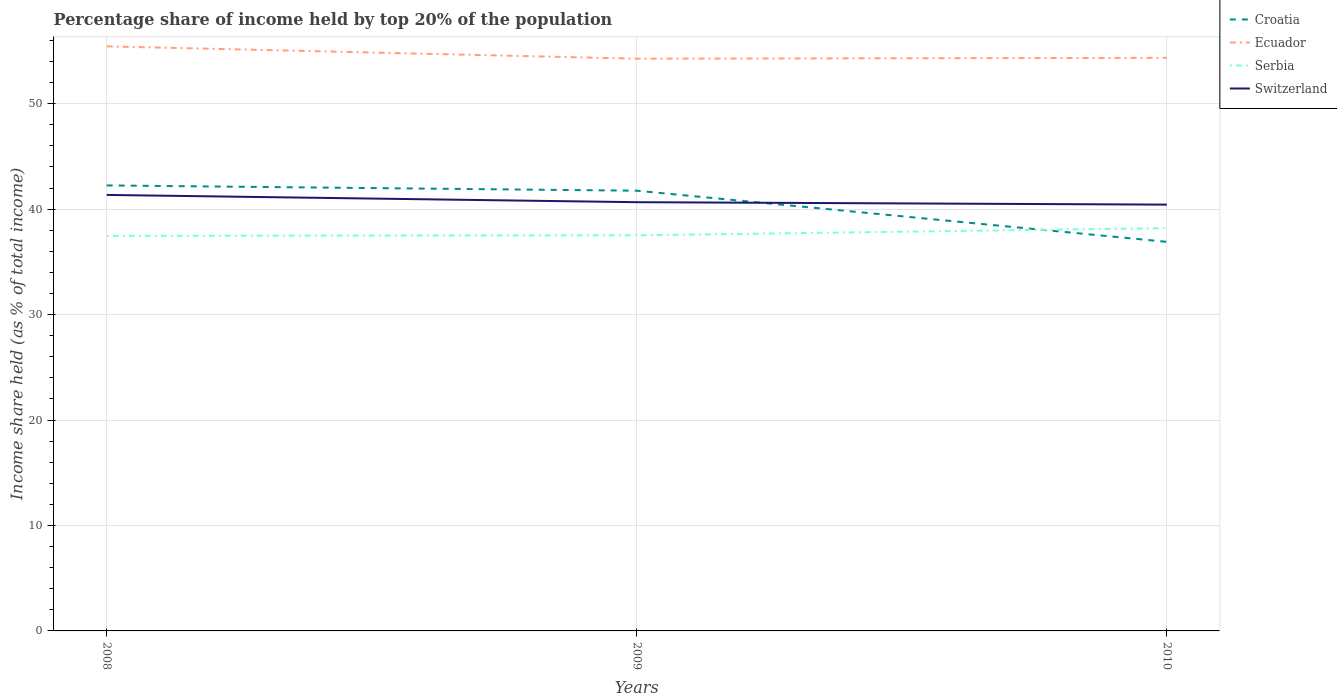How many different coloured lines are there?
Provide a succinct answer. 4. Does the line corresponding to Ecuador intersect with the line corresponding to Croatia?
Provide a succinct answer. No. Is the number of lines equal to the number of legend labels?
Give a very brief answer. Yes. Across all years, what is the maximum percentage share of income held by top 20% of the population in Serbia?
Your answer should be compact. 37.47. What is the total percentage share of income held by top 20% of the population in Switzerland in the graph?
Provide a short and direct response. 0.92. What is the difference between the highest and the second highest percentage share of income held by top 20% of the population in Ecuador?
Make the answer very short. 1.17. Is the percentage share of income held by top 20% of the population in Ecuador strictly greater than the percentage share of income held by top 20% of the population in Switzerland over the years?
Your answer should be compact. No. How many lines are there?
Your answer should be very brief. 4. How many years are there in the graph?
Your answer should be compact. 3. Does the graph contain any zero values?
Keep it short and to the point. No. Where does the legend appear in the graph?
Provide a short and direct response. Top right. How many legend labels are there?
Provide a succinct answer. 4. How are the legend labels stacked?
Your answer should be compact. Vertical. What is the title of the graph?
Ensure brevity in your answer.  Percentage share of income held by top 20% of the population. Does "Spain" appear as one of the legend labels in the graph?
Make the answer very short. No. What is the label or title of the X-axis?
Your response must be concise. Years. What is the label or title of the Y-axis?
Provide a short and direct response. Income share held (as % of total income). What is the Income share held (as % of total income) of Croatia in 2008?
Make the answer very short. 42.25. What is the Income share held (as % of total income) in Ecuador in 2008?
Your answer should be compact. 55.44. What is the Income share held (as % of total income) of Serbia in 2008?
Make the answer very short. 37.47. What is the Income share held (as % of total income) in Switzerland in 2008?
Provide a short and direct response. 41.35. What is the Income share held (as % of total income) of Croatia in 2009?
Give a very brief answer. 41.75. What is the Income share held (as % of total income) in Ecuador in 2009?
Make the answer very short. 54.27. What is the Income share held (as % of total income) of Serbia in 2009?
Provide a succinct answer. 37.52. What is the Income share held (as % of total income) in Switzerland in 2009?
Ensure brevity in your answer.  40.66. What is the Income share held (as % of total income) of Croatia in 2010?
Keep it short and to the point. 36.9. What is the Income share held (as % of total income) in Ecuador in 2010?
Offer a terse response. 54.35. What is the Income share held (as % of total income) of Serbia in 2010?
Provide a succinct answer. 38.2. What is the Income share held (as % of total income) of Switzerland in 2010?
Make the answer very short. 40.43. Across all years, what is the maximum Income share held (as % of total income) in Croatia?
Your response must be concise. 42.25. Across all years, what is the maximum Income share held (as % of total income) of Ecuador?
Offer a very short reply. 55.44. Across all years, what is the maximum Income share held (as % of total income) of Serbia?
Offer a very short reply. 38.2. Across all years, what is the maximum Income share held (as % of total income) of Switzerland?
Provide a succinct answer. 41.35. Across all years, what is the minimum Income share held (as % of total income) in Croatia?
Your answer should be compact. 36.9. Across all years, what is the minimum Income share held (as % of total income) of Ecuador?
Your answer should be compact. 54.27. Across all years, what is the minimum Income share held (as % of total income) of Serbia?
Your answer should be very brief. 37.47. Across all years, what is the minimum Income share held (as % of total income) in Switzerland?
Your answer should be compact. 40.43. What is the total Income share held (as % of total income) of Croatia in the graph?
Keep it short and to the point. 120.9. What is the total Income share held (as % of total income) of Ecuador in the graph?
Provide a succinct answer. 164.06. What is the total Income share held (as % of total income) of Serbia in the graph?
Your response must be concise. 113.19. What is the total Income share held (as % of total income) of Switzerland in the graph?
Your answer should be very brief. 122.44. What is the difference between the Income share held (as % of total income) of Croatia in 2008 and that in 2009?
Provide a short and direct response. 0.5. What is the difference between the Income share held (as % of total income) of Ecuador in 2008 and that in 2009?
Give a very brief answer. 1.17. What is the difference between the Income share held (as % of total income) of Switzerland in 2008 and that in 2009?
Offer a terse response. 0.69. What is the difference between the Income share held (as % of total income) of Croatia in 2008 and that in 2010?
Your answer should be very brief. 5.35. What is the difference between the Income share held (as % of total income) of Ecuador in 2008 and that in 2010?
Provide a succinct answer. 1.09. What is the difference between the Income share held (as % of total income) in Serbia in 2008 and that in 2010?
Your answer should be compact. -0.73. What is the difference between the Income share held (as % of total income) of Croatia in 2009 and that in 2010?
Provide a short and direct response. 4.85. What is the difference between the Income share held (as % of total income) of Ecuador in 2009 and that in 2010?
Offer a terse response. -0.08. What is the difference between the Income share held (as % of total income) of Serbia in 2009 and that in 2010?
Provide a succinct answer. -0.68. What is the difference between the Income share held (as % of total income) of Switzerland in 2009 and that in 2010?
Offer a terse response. 0.23. What is the difference between the Income share held (as % of total income) in Croatia in 2008 and the Income share held (as % of total income) in Ecuador in 2009?
Keep it short and to the point. -12.02. What is the difference between the Income share held (as % of total income) in Croatia in 2008 and the Income share held (as % of total income) in Serbia in 2009?
Give a very brief answer. 4.73. What is the difference between the Income share held (as % of total income) in Croatia in 2008 and the Income share held (as % of total income) in Switzerland in 2009?
Ensure brevity in your answer.  1.59. What is the difference between the Income share held (as % of total income) in Ecuador in 2008 and the Income share held (as % of total income) in Serbia in 2009?
Your response must be concise. 17.92. What is the difference between the Income share held (as % of total income) of Ecuador in 2008 and the Income share held (as % of total income) of Switzerland in 2009?
Provide a succinct answer. 14.78. What is the difference between the Income share held (as % of total income) of Serbia in 2008 and the Income share held (as % of total income) of Switzerland in 2009?
Give a very brief answer. -3.19. What is the difference between the Income share held (as % of total income) of Croatia in 2008 and the Income share held (as % of total income) of Serbia in 2010?
Offer a terse response. 4.05. What is the difference between the Income share held (as % of total income) in Croatia in 2008 and the Income share held (as % of total income) in Switzerland in 2010?
Offer a terse response. 1.82. What is the difference between the Income share held (as % of total income) of Ecuador in 2008 and the Income share held (as % of total income) of Serbia in 2010?
Offer a terse response. 17.24. What is the difference between the Income share held (as % of total income) in Ecuador in 2008 and the Income share held (as % of total income) in Switzerland in 2010?
Provide a succinct answer. 15.01. What is the difference between the Income share held (as % of total income) in Serbia in 2008 and the Income share held (as % of total income) in Switzerland in 2010?
Your answer should be very brief. -2.96. What is the difference between the Income share held (as % of total income) in Croatia in 2009 and the Income share held (as % of total income) in Serbia in 2010?
Your answer should be compact. 3.55. What is the difference between the Income share held (as % of total income) in Croatia in 2009 and the Income share held (as % of total income) in Switzerland in 2010?
Provide a short and direct response. 1.32. What is the difference between the Income share held (as % of total income) of Ecuador in 2009 and the Income share held (as % of total income) of Serbia in 2010?
Your response must be concise. 16.07. What is the difference between the Income share held (as % of total income) of Ecuador in 2009 and the Income share held (as % of total income) of Switzerland in 2010?
Ensure brevity in your answer.  13.84. What is the difference between the Income share held (as % of total income) of Serbia in 2009 and the Income share held (as % of total income) of Switzerland in 2010?
Offer a terse response. -2.91. What is the average Income share held (as % of total income) in Croatia per year?
Give a very brief answer. 40.3. What is the average Income share held (as % of total income) of Ecuador per year?
Ensure brevity in your answer.  54.69. What is the average Income share held (as % of total income) in Serbia per year?
Provide a short and direct response. 37.73. What is the average Income share held (as % of total income) in Switzerland per year?
Your response must be concise. 40.81. In the year 2008, what is the difference between the Income share held (as % of total income) of Croatia and Income share held (as % of total income) of Ecuador?
Make the answer very short. -13.19. In the year 2008, what is the difference between the Income share held (as % of total income) in Croatia and Income share held (as % of total income) in Serbia?
Keep it short and to the point. 4.78. In the year 2008, what is the difference between the Income share held (as % of total income) in Ecuador and Income share held (as % of total income) in Serbia?
Offer a very short reply. 17.97. In the year 2008, what is the difference between the Income share held (as % of total income) of Ecuador and Income share held (as % of total income) of Switzerland?
Ensure brevity in your answer.  14.09. In the year 2008, what is the difference between the Income share held (as % of total income) of Serbia and Income share held (as % of total income) of Switzerland?
Your answer should be very brief. -3.88. In the year 2009, what is the difference between the Income share held (as % of total income) of Croatia and Income share held (as % of total income) of Ecuador?
Ensure brevity in your answer.  -12.52. In the year 2009, what is the difference between the Income share held (as % of total income) in Croatia and Income share held (as % of total income) in Serbia?
Make the answer very short. 4.23. In the year 2009, what is the difference between the Income share held (as % of total income) of Croatia and Income share held (as % of total income) of Switzerland?
Offer a very short reply. 1.09. In the year 2009, what is the difference between the Income share held (as % of total income) in Ecuador and Income share held (as % of total income) in Serbia?
Provide a succinct answer. 16.75. In the year 2009, what is the difference between the Income share held (as % of total income) in Ecuador and Income share held (as % of total income) in Switzerland?
Offer a terse response. 13.61. In the year 2009, what is the difference between the Income share held (as % of total income) of Serbia and Income share held (as % of total income) of Switzerland?
Provide a succinct answer. -3.14. In the year 2010, what is the difference between the Income share held (as % of total income) in Croatia and Income share held (as % of total income) in Ecuador?
Your answer should be very brief. -17.45. In the year 2010, what is the difference between the Income share held (as % of total income) of Croatia and Income share held (as % of total income) of Serbia?
Offer a terse response. -1.3. In the year 2010, what is the difference between the Income share held (as % of total income) of Croatia and Income share held (as % of total income) of Switzerland?
Your answer should be very brief. -3.53. In the year 2010, what is the difference between the Income share held (as % of total income) of Ecuador and Income share held (as % of total income) of Serbia?
Your response must be concise. 16.15. In the year 2010, what is the difference between the Income share held (as % of total income) of Ecuador and Income share held (as % of total income) of Switzerland?
Provide a short and direct response. 13.92. In the year 2010, what is the difference between the Income share held (as % of total income) in Serbia and Income share held (as % of total income) in Switzerland?
Provide a short and direct response. -2.23. What is the ratio of the Income share held (as % of total income) in Croatia in 2008 to that in 2009?
Provide a short and direct response. 1.01. What is the ratio of the Income share held (as % of total income) in Ecuador in 2008 to that in 2009?
Make the answer very short. 1.02. What is the ratio of the Income share held (as % of total income) of Serbia in 2008 to that in 2009?
Offer a terse response. 1. What is the ratio of the Income share held (as % of total income) of Switzerland in 2008 to that in 2009?
Give a very brief answer. 1.02. What is the ratio of the Income share held (as % of total income) in Croatia in 2008 to that in 2010?
Your answer should be compact. 1.15. What is the ratio of the Income share held (as % of total income) in Ecuador in 2008 to that in 2010?
Your answer should be very brief. 1.02. What is the ratio of the Income share held (as % of total income) in Serbia in 2008 to that in 2010?
Your answer should be very brief. 0.98. What is the ratio of the Income share held (as % of total income) of Switzerland in 2008 to that in 2010?
Your answer should be very brief. 1.02. What is the ratio of the Income share held (as % of total income) of Croatia in 2009 to that in 2010?
Make the answer very short. 1.13. What is the ratio of the Income share held (as % of total income) in Serbia in 2009 to that in 2010?
Ensure brevity in your answer.  0.98. What is the difference between the highest and the second highest Income share held (as % of total income) of Ecuador?
Ensure brevity in your answer.  1.09. What is the difference between the highest and the second highest Income share held (as % of total income) in Serbia?
Ensure brevity in your answer.  0.68. What is the difference between the highest and the second highest Income share held (as % of total income) in Switzerland?
Your response must be concise. 0.69. What is the difference between the highest and the lowest Income share held (as % of total income) in Croatia?
Your answer should be compact. 5.35. What is the difference between the highest and the lowest Income share held (as % of total income) of Ecuador?
Your answer should be very brief. 1.17. What is the difference between the highest and the lowest Income share held (as % of total income) in Serbia?
Ensure brevity in your answer.  0.73. 